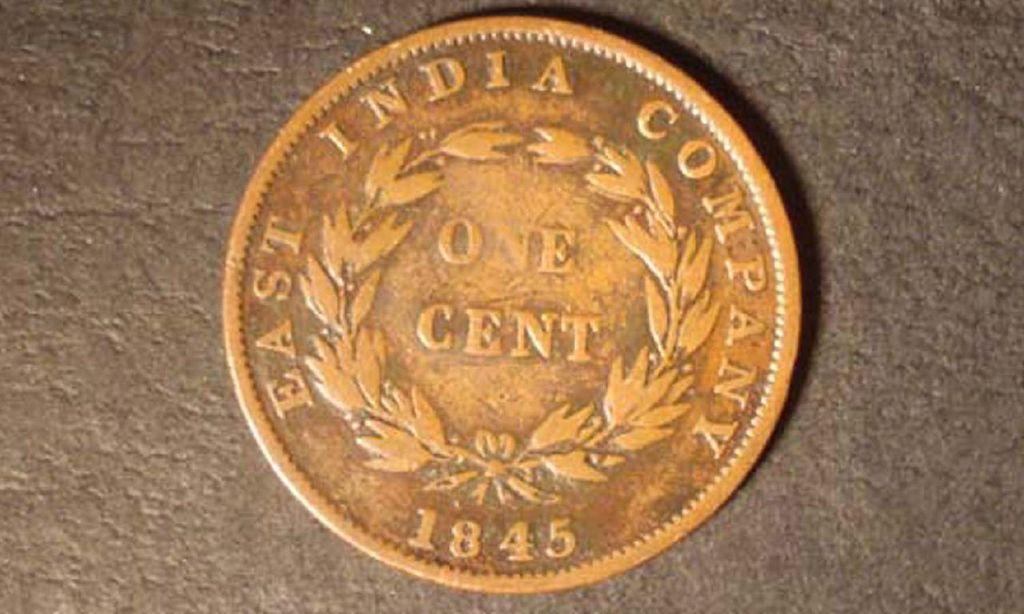<image>
Write a terse but informative summary of the picture. A once cent East India Company coin from 1845 sits on a countertop. 